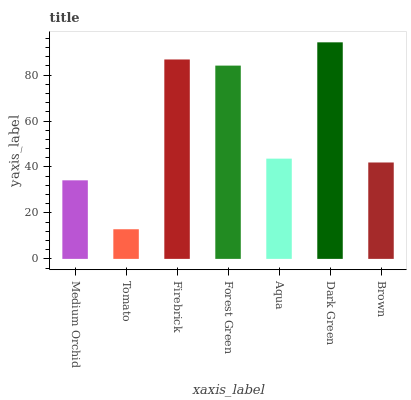Is Tomato the minimum?
Answer yes or no. Yes. Is Dark Green the maximum?
Answer yes or no. Yes. Is Firebrick the minimum?
Answer yes or no. No. Is Firebrick the maximum?
Answer yes or no. No. Is Firebrick greater than Tomato?
Answer yes or no. Yes. Is Tomato less than Firebrick?
Answer yes or no. Yes. Is Tomato greater than Firebrick?
Answer yes or no. No. Is Firebrick less than Tomato?
Answer yes or no. No. Is Aqua the high median?
Answer yes or no. Yes. Is Aqua the low median?
Answer yes or no. Yes. Is Forest Green the high median?
Answer yes or no. No. Is Dark Green the low median?
Answer yes or no. No. 